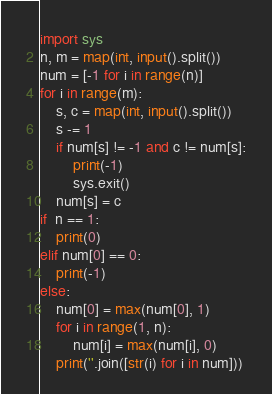<code> <loc_0><loc_0><loc_500><loc_500><_Python_>import sys
n, m = map(int, input().split())
num = [-1 for i in range(n)]
for i in range(m):
    s, c = map(int, input().split())
    s -= 1
    if num[s] != -1 and c != num[s]:
        print(-1)
        sys.exit()
    num[s] = c
if  n == 1:
    print(0)
elif num[0] == 0:
    print(-1)
else:
    num[0] = max(num[0], 1)
    for i in range(1, n):
        num[i] = max(num[i], 0)
    print(''.join([str(i) for i in num]))</code> 